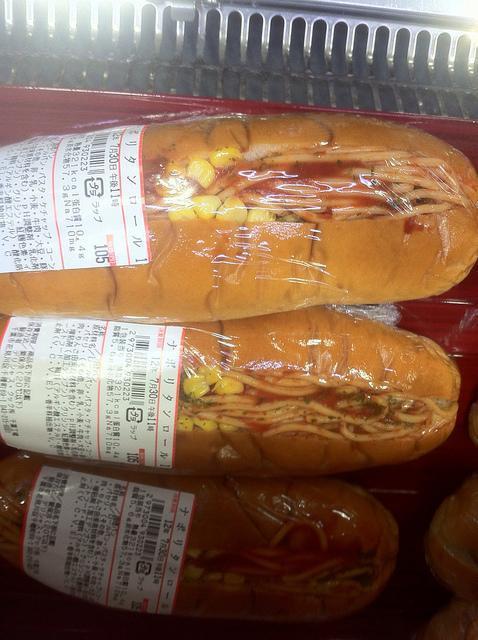How many sandwiches are in the photo?
Give a very brief answer. 3. 